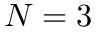Convert formula to latex. <formula><loc_0><loc_0><loc_500><loc_500>N = 3</formula> 